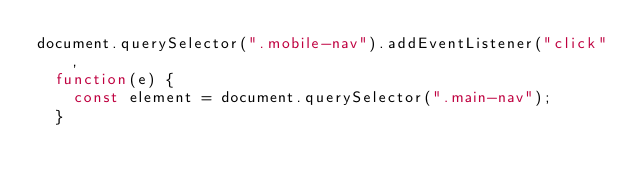<code> <loc_0><loc_0><loc_500><loc_500><_JavaScript_>document.querySelector(".mobile-nav").addEventListener("click",
  function(e) {
    const element = document.querySelector(".main-nav");
  }</code> 